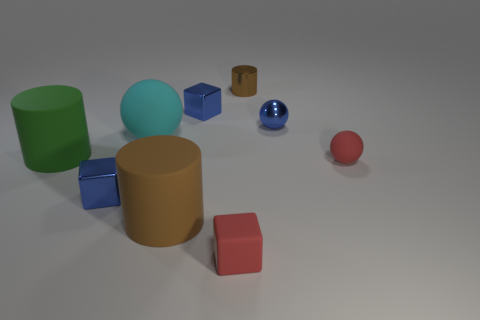What number of other objects are the same shape as the large cyan object?
Give a very brief answer. 2. Do the small blue ball left of the red rubber ball and the tiny brown thing have the same material?
Make the answer very short. Yes. How many objects are either tiny spheres or green rubber cylinders?
Provide a short and direct response. 3. There is a green rubber object that is the same shape as the big brown matte object; what is its size?
Make the answer very short. Large. The cyan matte thing is what size?
Provide a succinct answer. Large. Are there more big rubber cylinders in front of the green rubber thing than tiny cyan matte objects?
Provide a short and direct response. Yes. Is there any other thing that has the same material as the big cyan thing?
Provide a short and direct response. Yes. There is a big rubber object in front of the large green object; does it have the same color as the shiny thing that is in front of the large cyan object?
Offer a terse response. No. There is a blue block left of the tiny blue block on the right side of the matte cylinder right of the cyan sphere; what is it made of?
Provide a succinct answer. Metal. Are there more brown metallic cylinders than red objects?
Your response must be concise. No. 